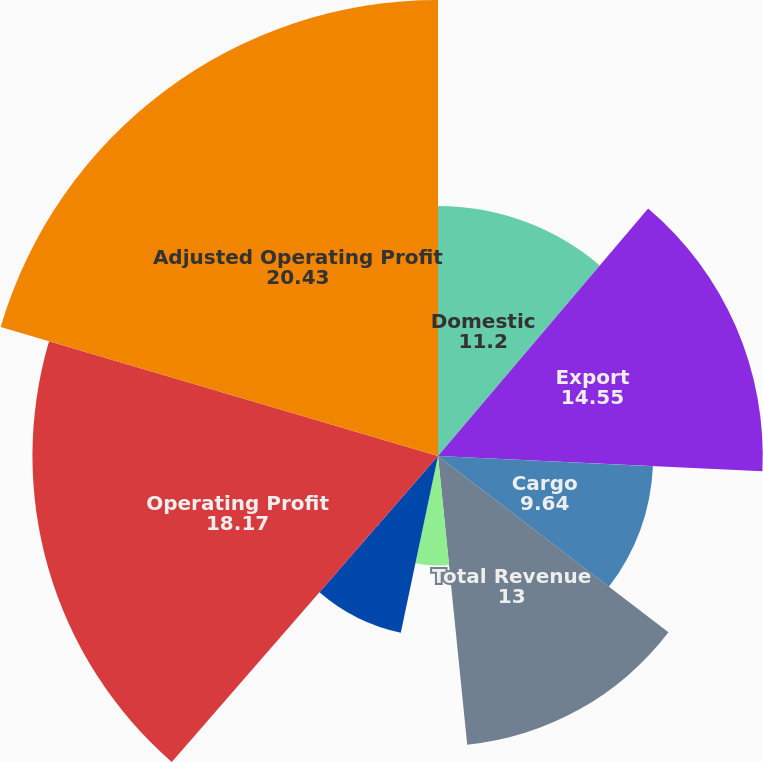Convert chart to OTSL. <chart><loc_0><loc_0><loc_500><loc_500><pie_chart><fcel>Domestic<fcel>Export<fcel>Cargo<fcel>Total Revenue<fcel>Total Avg Daily Package Volume<fcel>Total Avg Revenue Per Piece<fcel>Operating Profit<fcel>Adjusted Operating Profit<nl><fcel>11.2%<fcel>14.55%<fcel>9.64%<fcel>13.0%<fcel>4.91%<fcel>8.09%<fcel>18.17%<fcel>20.43%<nl></chart> 